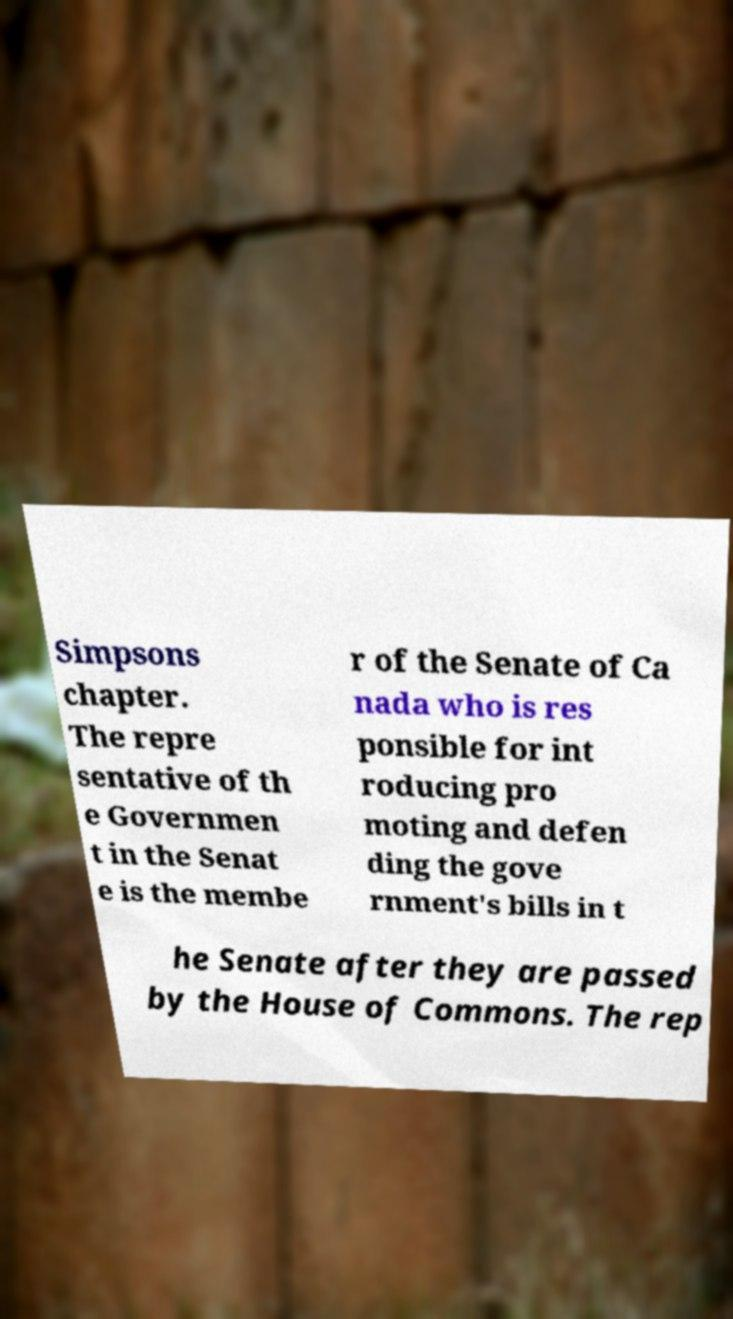Could you extract and type out the text from this image? Simpsons chapter. The repre sentative of th e Governmen t in the Senat e is the membe r of the Senate of Ca nada who is res ponsible for int roducing pro moting and defen ding the gove rnment's bills in t he Senate after they are passed by the House of Commons. The rep 